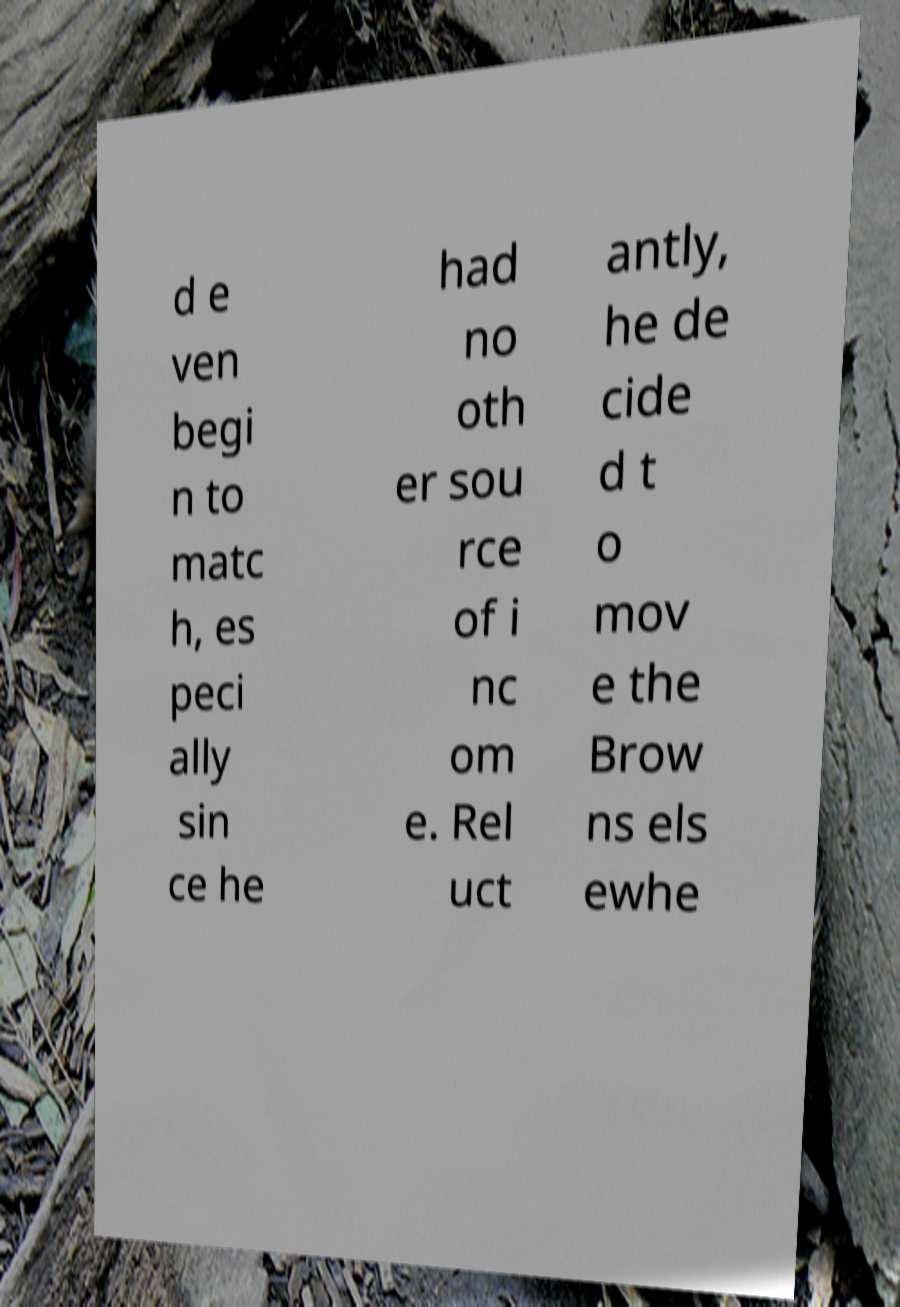Could you extract and type out the text from this image? d e ven begi n to matc h, es peci ally sin ce he had no oth er sou rce of i nc om e. Rel uct antly, he de cide d t o mov e the Brow ns els ewhe 